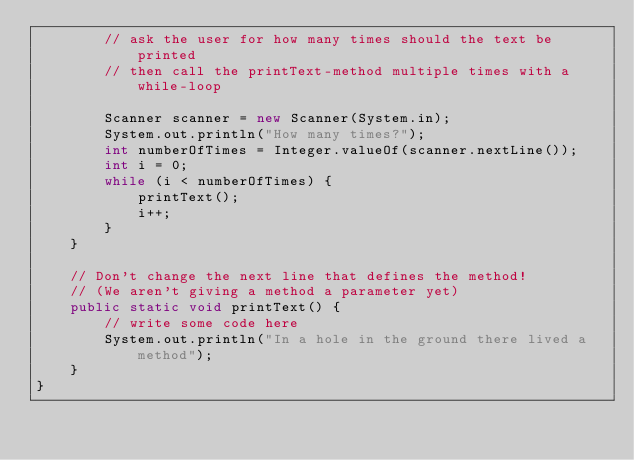Convert code to text. <code><loc_0><loc_0><loc_500><loc_500><_Java_>        // ask the user for how many times should the text be printed
        // then call the printText-method multiple times with a while-loop
        
        Scanner scanner = new Scanner(System.in);
        System.out.println("How many times?");
        int numberOfTimes = Integer.valueOf(scanner.nextLine());
        int i = 0;
        while (i < numberOfTimes) {
            printText();
            i++;
        }
    }
    
    // Don't change the next line that defines the method!
    // (We aren't giving a method a parameter yet)
    public static void printText() {
        // write some code here
        System.out.println("In a hole in the ground there lived a method");
    }
}
</code> 